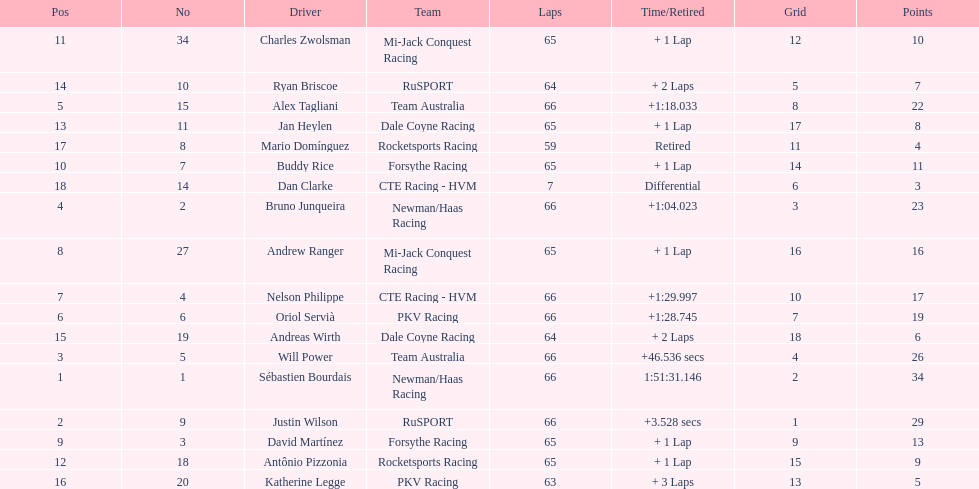At the 2006 gran premio telmex, how many drivers completed less than 60 laps? 2. 